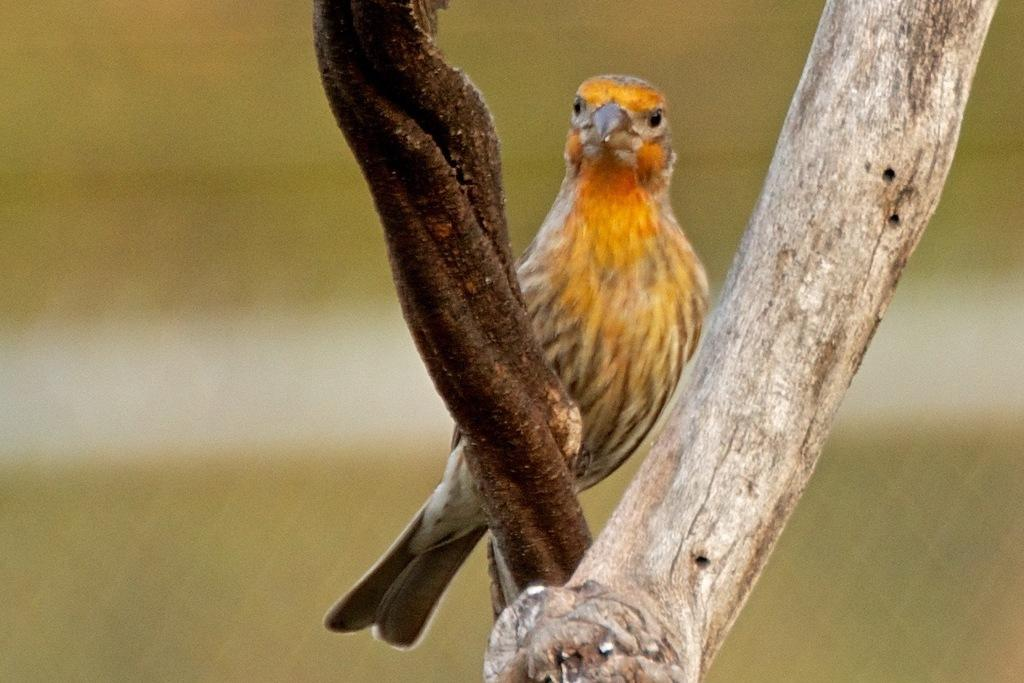What type of animal is in the image? There is a bird in the image. Where is the bird located? The bird is on the branch of a tree. What colors can be seen on the bird? The bird has orange and brown colors. Can you describe the background of the image? The background of the image is blurred. What type of loaf can be seen in the image? There is no loaf present in the image; it features a bird on a tree branch. Can you tell me how many cellars are visible in the image? There are no cellars visible in the image. 